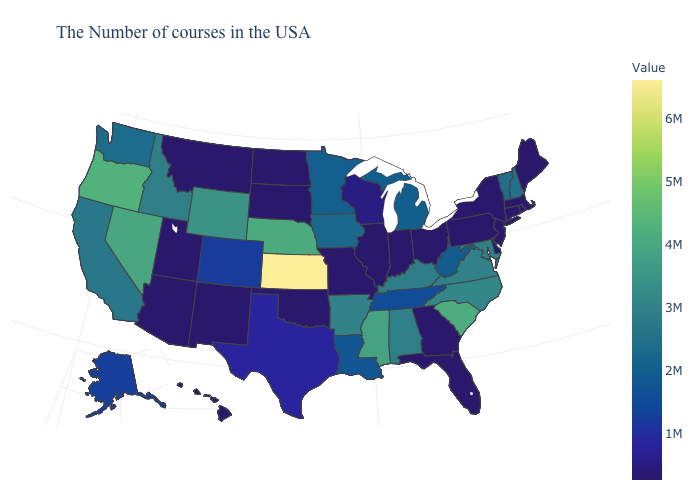Is the legend a continuous bar?
Keep it brief. Yes. Which states hav the highest value in the Northeast?
Give a very brief answer. New Hampshire. Which states have the highest value in the USA?
Short answer required. Kansas. Among the states that border Minnesota , does Wisconsin have the lowest value?
Quick response, please. No. Does Iowa have the lowest value in the MidWest?
Keep it brief. No. 